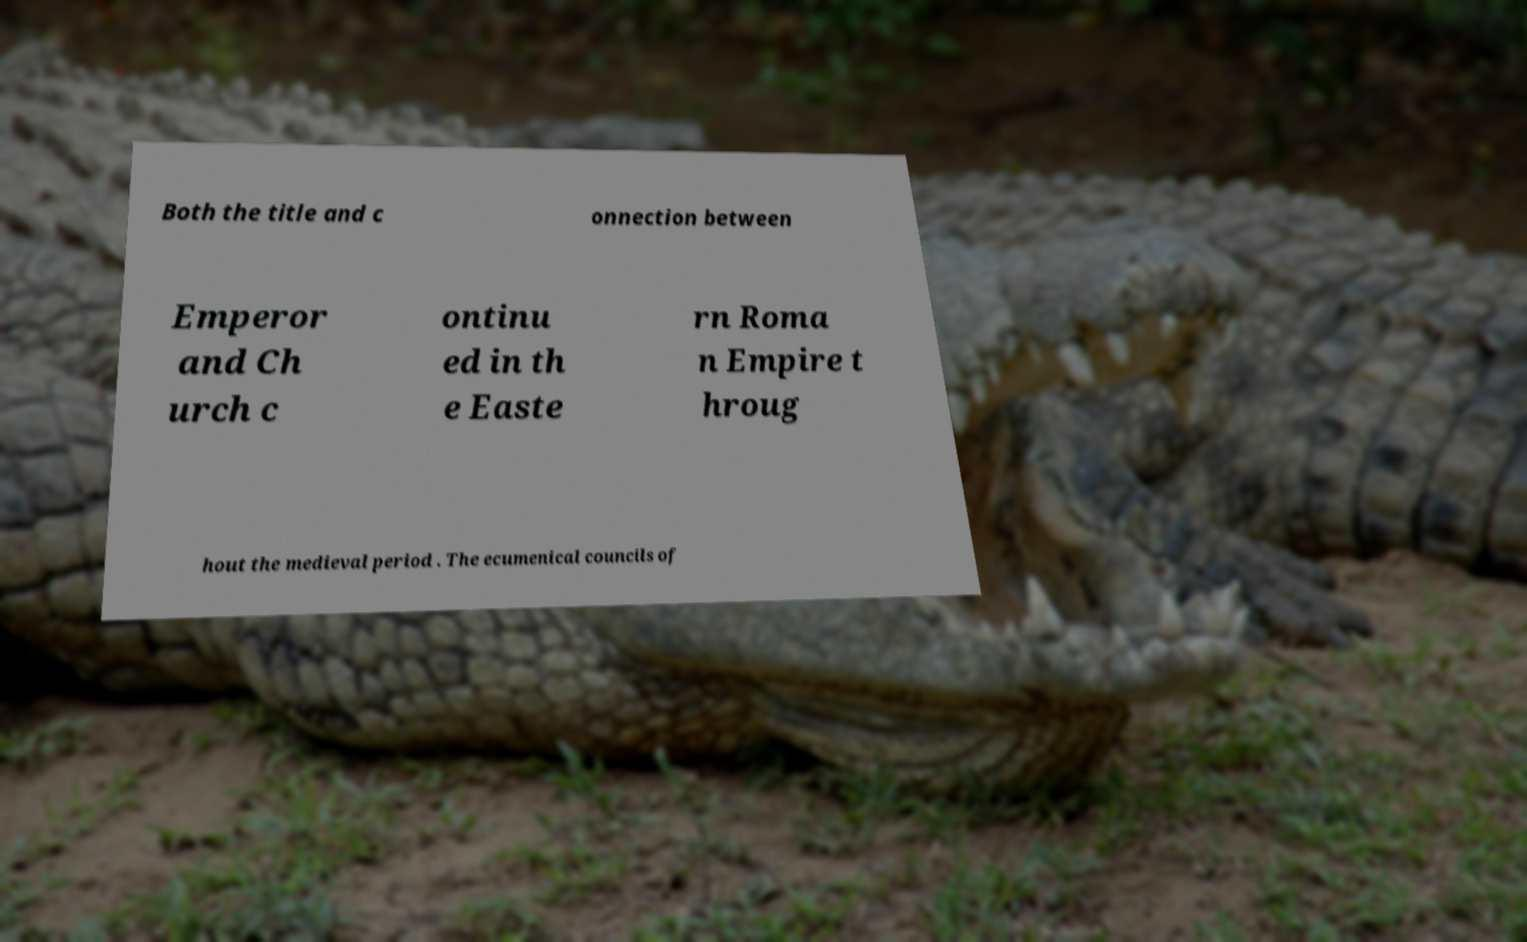For documentation purposes, I need the text within this image transcribed. Could you provide that? Both the title and c onnection between Emperor and Ch urch c ontinu ed in th e Easte rn Roma n Empire t hroug hout the medieval period . The ecumenical councils of 